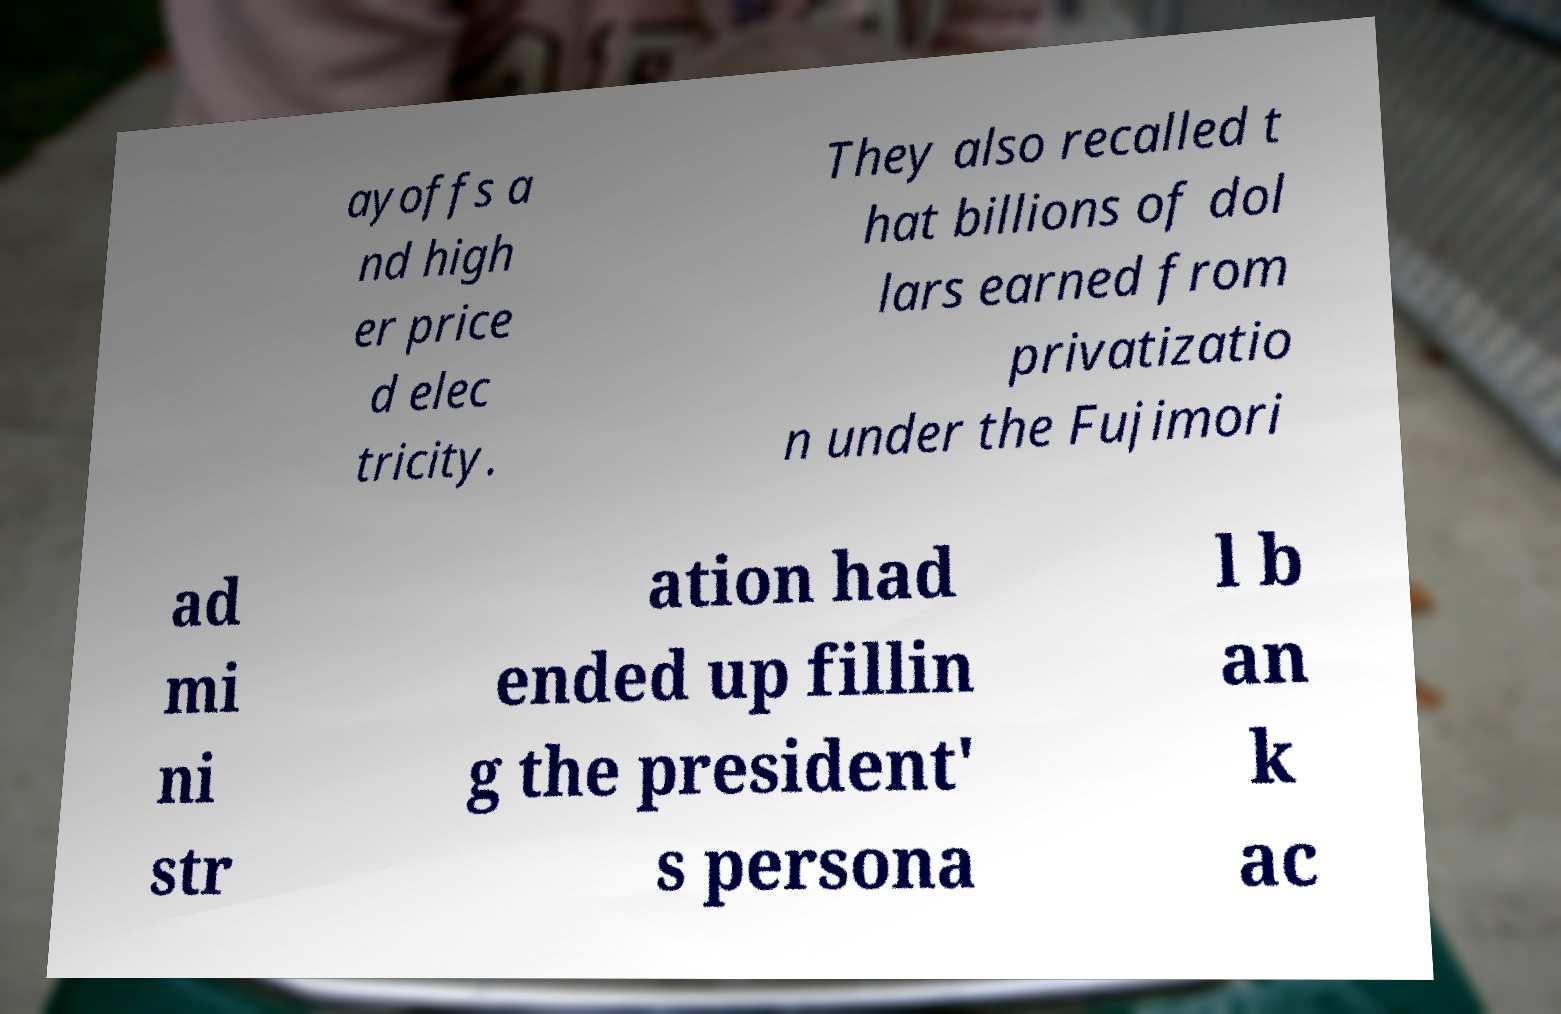Can you read and provide the text displayed in the image?This photo seems to have some interesting text. Can you extract and type it out for me? ayoffs a nd high er price d elec tricity. They also recalled t hat billions of dol lars earned from privatizatio n under the Fujimori ad mi ni str ation had ended up fillin g the president' s persona l b an k ac 